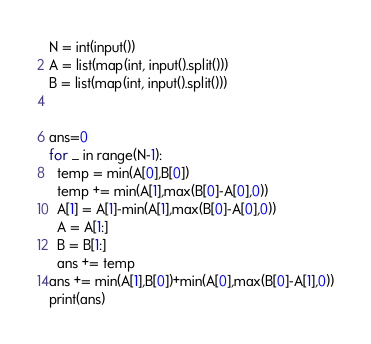Convert code to text. <code><loc_0><loc_0><loc_500><loc_500><_Python_>N = int(input())
A = list(map(int, input().split()))
B = list(map(int, input().split()))


ans=0
for _ in range(N-1):
  temp = min(A[0],B[0])
  temp += min(A[1],max(B[0]-A[0],0))
  A[1] = A[1]-min(A[1],max(B[0]-A[0],0))
  A = A[1:]
  B = B[1:]
  ans += temp
ans += min(A[1],B[0])+min(A[0],max(B[0]-A[1],0))
print(ans)</code> 